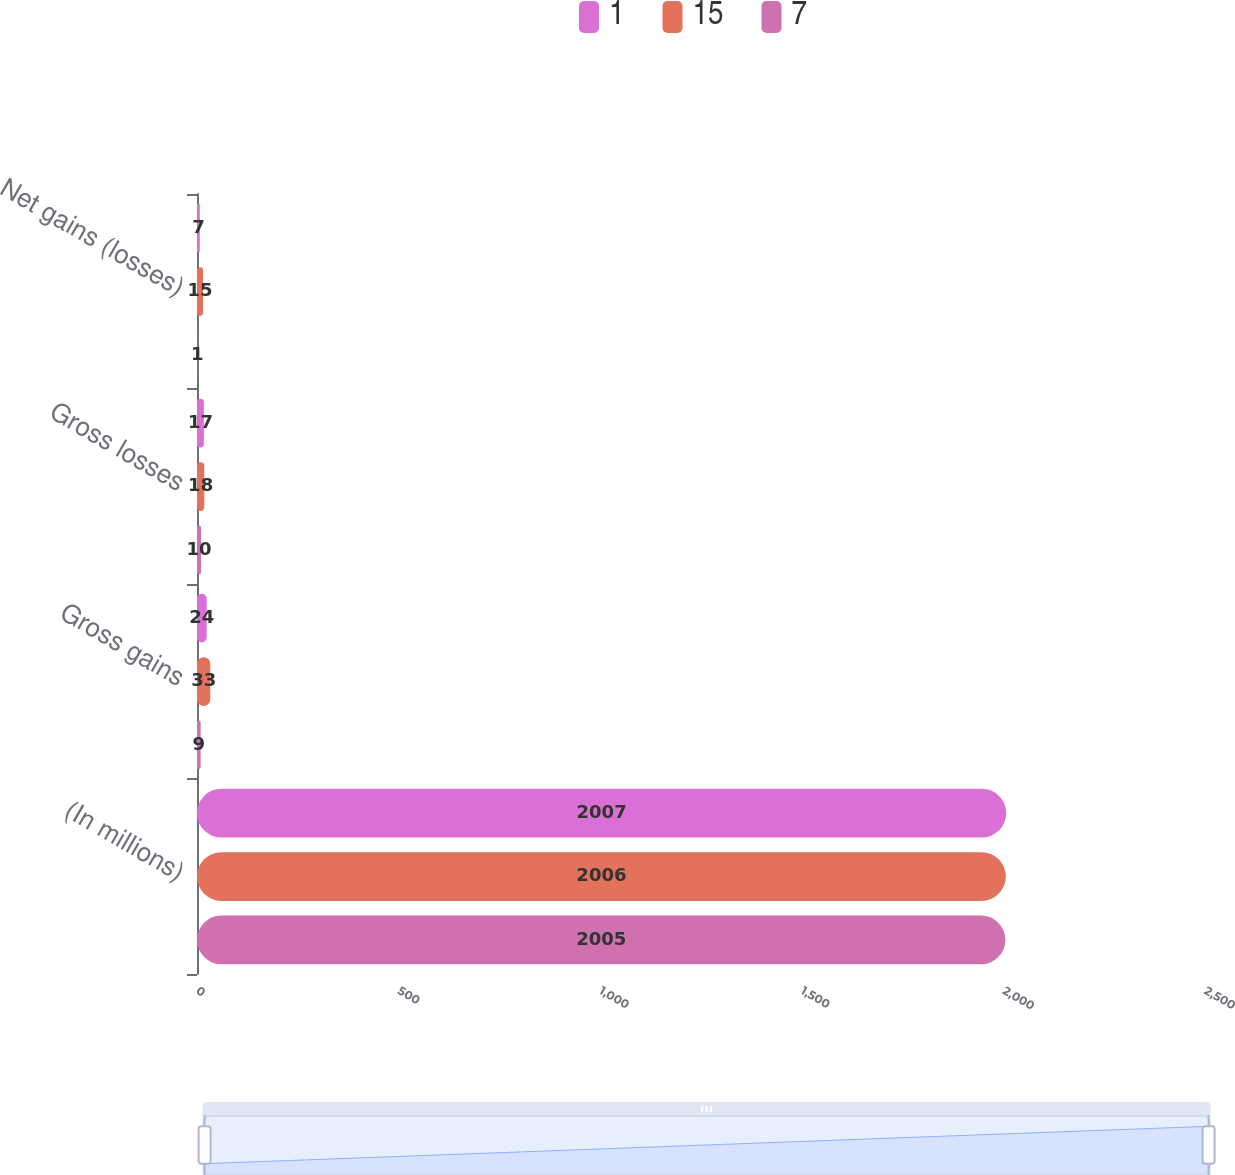Convert chart. <chart><loc_0><loc_0><loc_500><loc_500><stacked_bar_chart><ecel><fcel>(In millions)<fcel>Gross gains<fcel>Gross losses<fcel>Net gains (losses)<nl><fcel>1<fcel>2007<fcel>24<fcel>17<fcel>7<nl><fcel>15<fcel>2006<fcel>33<fcel>18<fcel>15<nl><fcel>7<fcel>2005<fcel>9<fcel>10<fcel>1<nl></chart> 